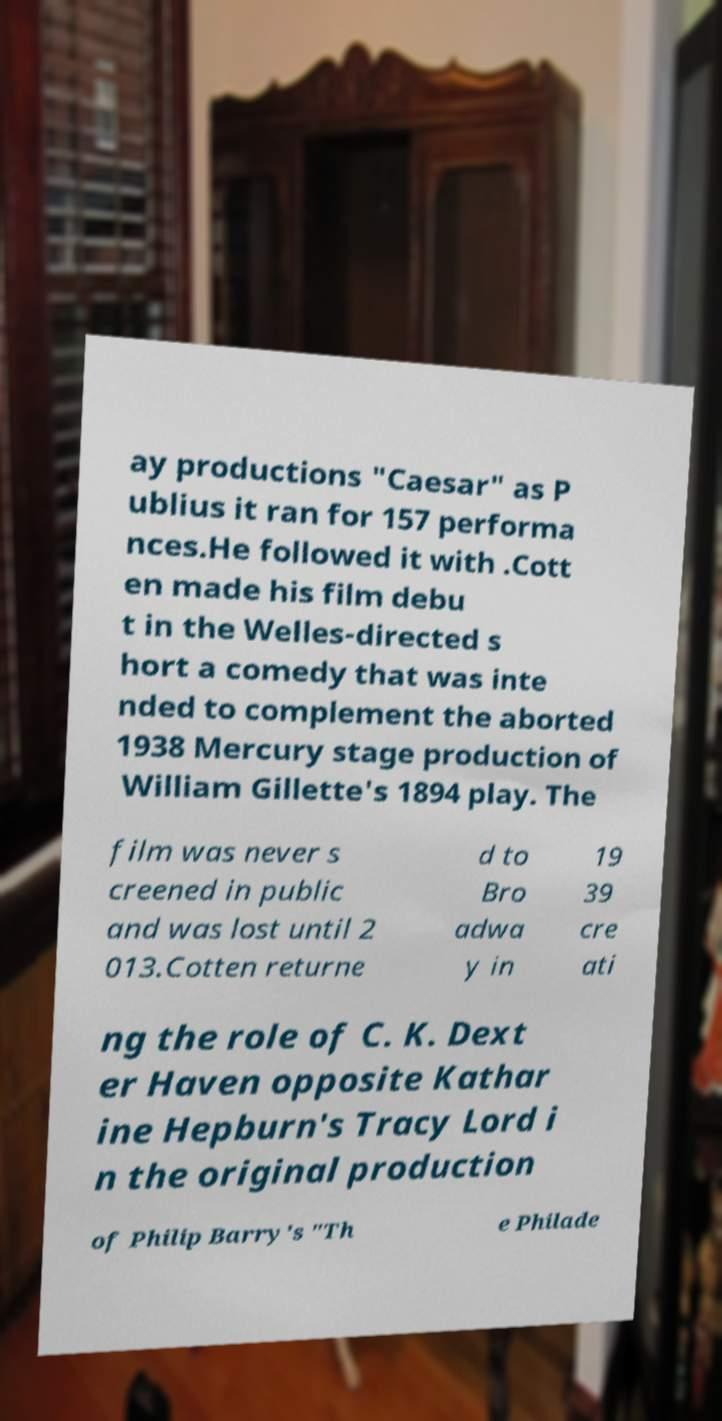There's text embedded in this image that I need extracted. Can you transcribe it verbatim? ay productions "Caesar" as P ublius it ran for 157 performa nces.He followed it with .Cott en made his film debu t in the Welles-directed s hort a comedy that was inte nded to complement the aborted 1938 Mercury stage production of William Gillette's 1894 play. The film was never s creened in public and was lost until 2 013.Cotten returne d to Bro adwa y in 19 39 cre ati ng the role of C. K. Dext er Haven opposite Kathar ine Hepburn's Tracy Lord i n the original production of Philip Barry's "Th e Philade 